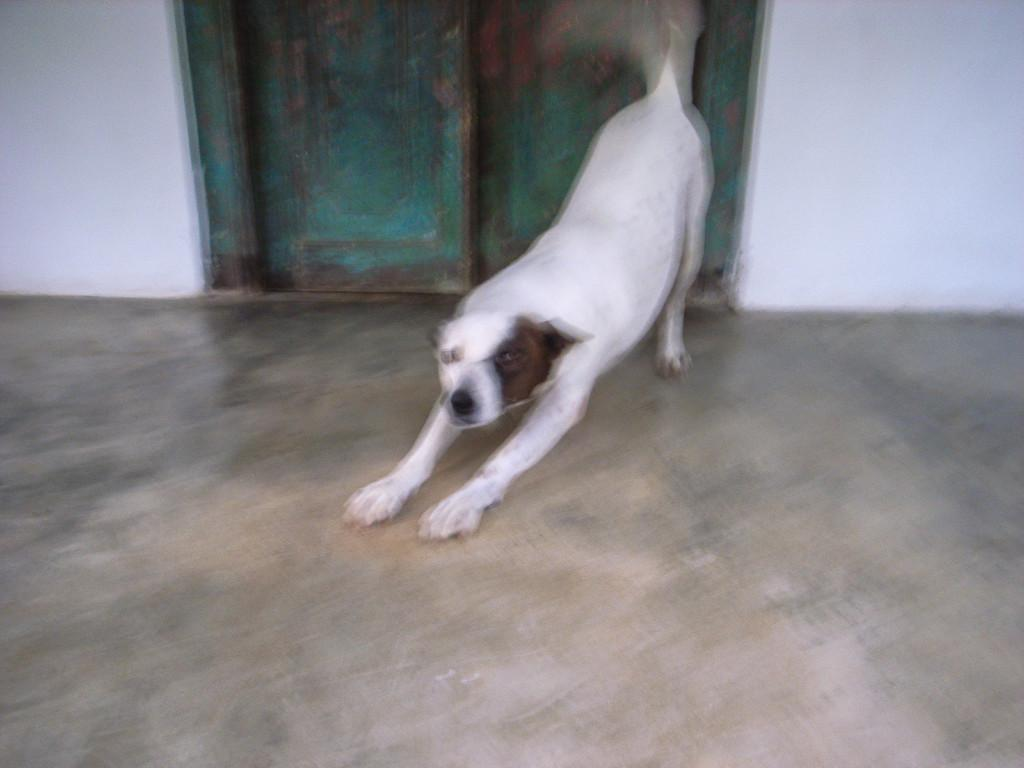What is the main subject in the center of the image? There is a dog in the center of the image. What type of surface is visible at the bottom of the image? There is a floor visible at the bottom of the image. What can be seen in the background of the image? There is a wall and doors in the background of the image. What type of underwear is the dog wearing in the image? Dogs do not wear underwear, and there is no underwear visible in the image. How many rings can be seen on the dog's tail in the image? There are no rings visible on the dog's tail in the image. 